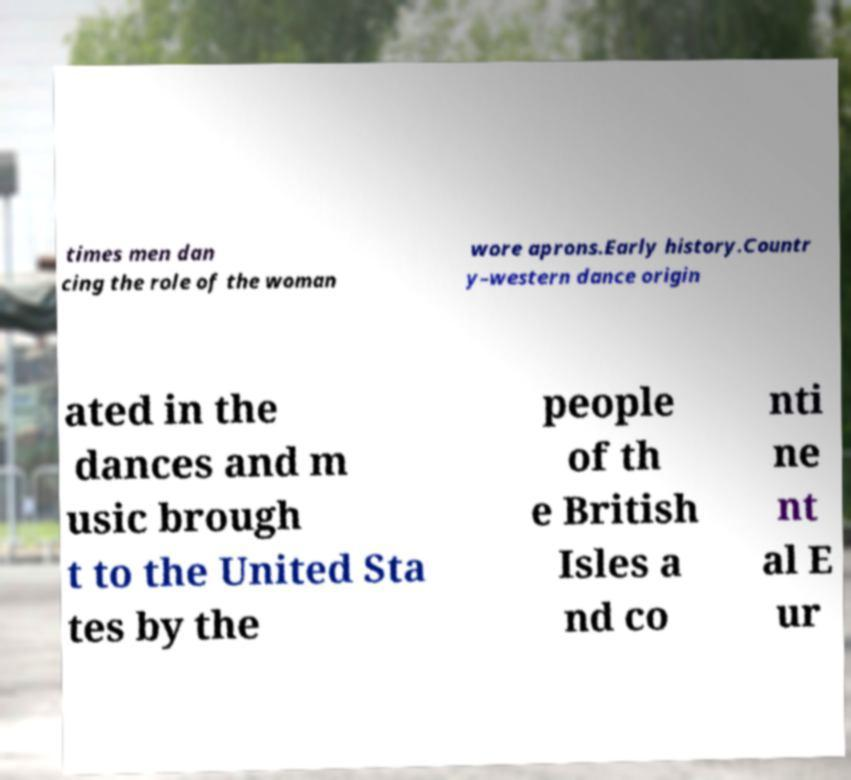Please read and relay the text visible in this image. What does it say? times men dan cing the role of the woman wore aprons.Early history.Countr y–western dance origin ated in the dances and m usic brough t to the United Sta tes by the people of th e British Isles a nd co nti ne nt al E ur 